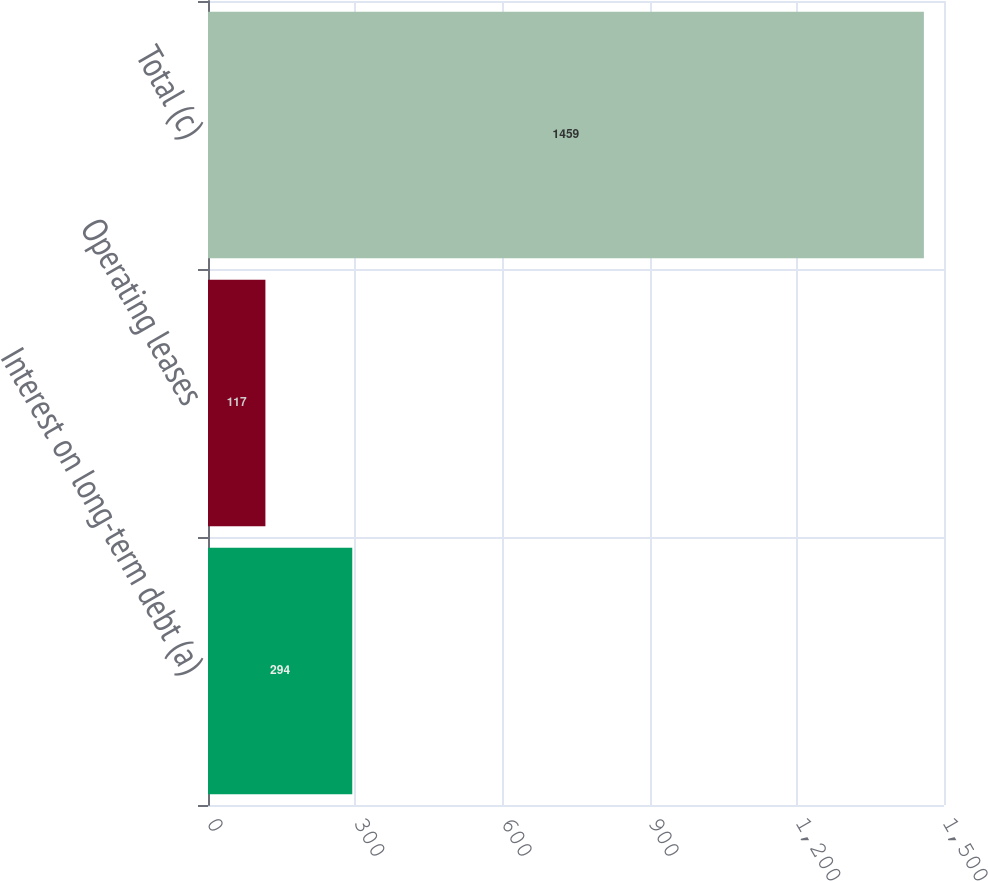<chart> <loc_0><loc_0><loc_500><loc_500><bar_chart><fcel>Interest on long-term debt (a)<fcel>Operating leases<fcel>Total (c)<nl><fcel>294<fcel>117<fcel>1459<nl></chart> 